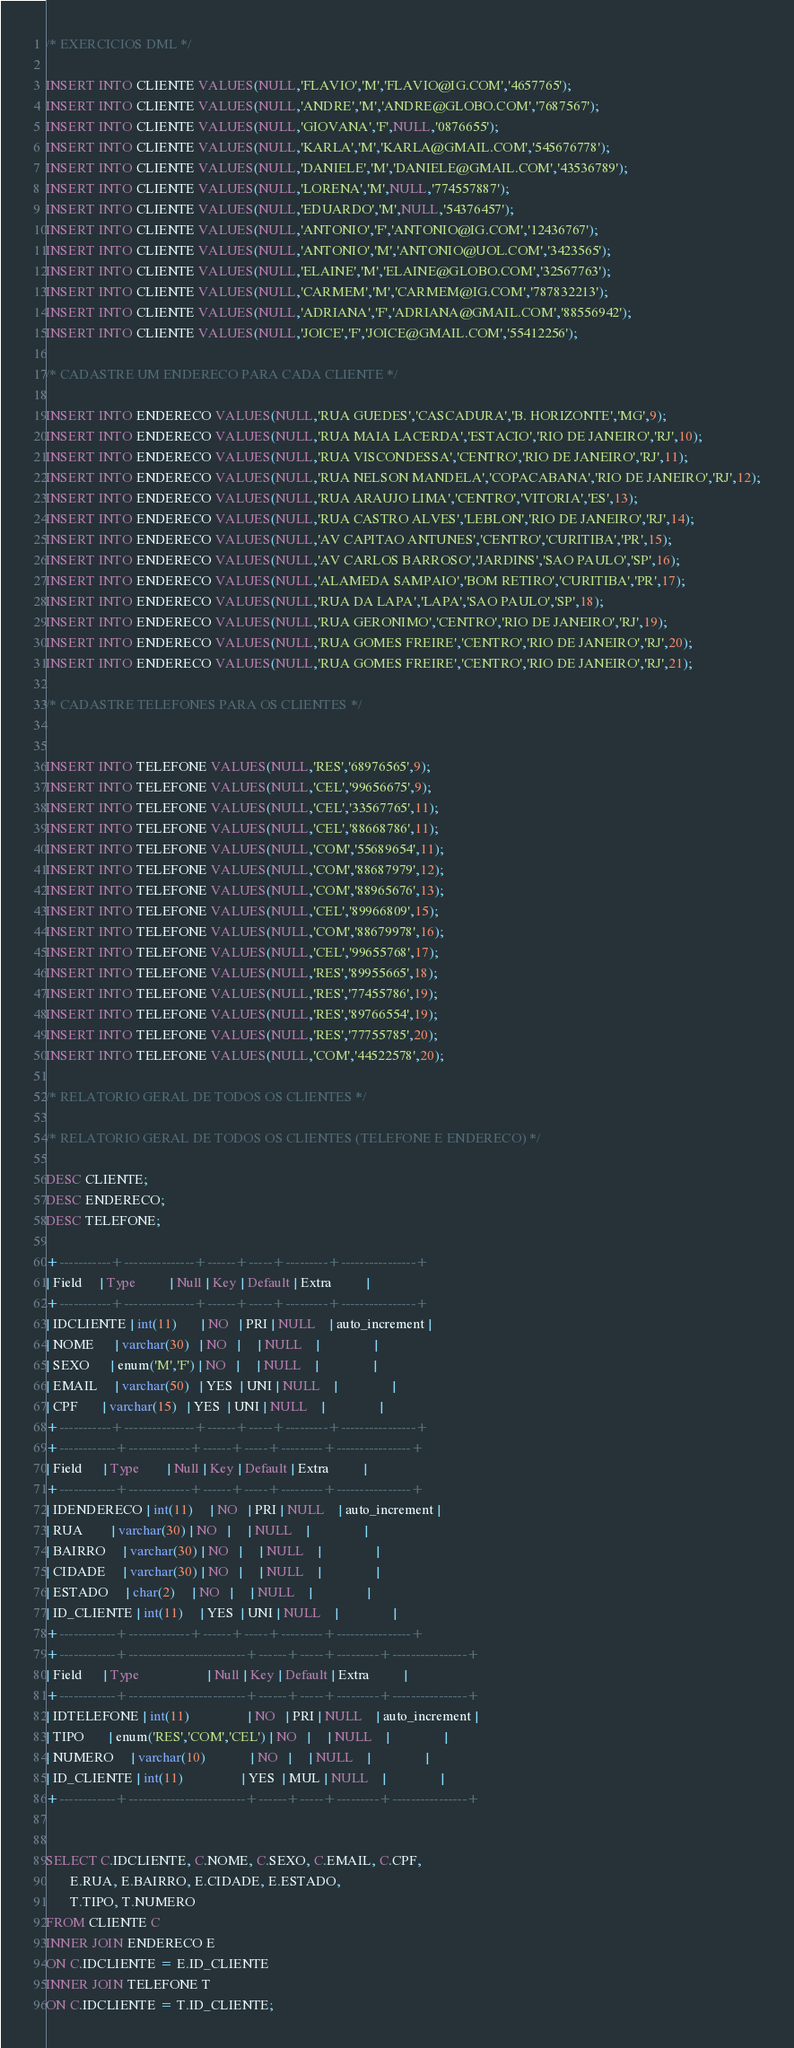<code> <loc_0><loc_0><loc_500><loc_500><_SQL_>/* EXERCICIOS DML */

INSERT INTO CLIENTE VALUES(NULL,'FLAVIO','M','FLAVIO@IG.COM','4657765');
INSERT INTO CLIENTE VALUES(NULL,'ANDRE','M','ANDRE@GLOBO.COM','7687567');
INSERT INTO CLIENTE VALUES(NULL,'GIOVANA','F',NULL,'0876655');
INSERT INTO CLIENTE VALUES(NULL,'KARLA','M','KARLA@GMAIL.COM','545676778');
INSERT INTO CLIENTE VALUES(NULL,'DANIELE','M','DANIELE@GMAIL.COM','43536789');
INSERT INTO CLIENTE VALUES(NULL,'LORENA','M',NULL,'774557887');
INSERT INTO CLIENTE VALUES(NULL,'EDUARDO','M',NULL,'54376457');
INSERT INTO CLIENTE VALUES(NULL,'ANTONIO','F','ANTONIO@IG.COM','12436767');
INSERT INTO CLIENTE VALUES(NULL,'ANTONIO','M','ANTONIO@UOL.COM','3423565');
INSERT INTO CLIENTE VALUES(NULL,'ELAINE','M','ELAINE@GLOBO.COM','32567763');
INSERT INTO CLIENTE VALUES(NULL,'CARMEM','M','CARMEM@IG.COM','787832213');
INSERT INTO CLIENTE VALUES(NULL,'ADRIANA','F','ADRIANA@GMAIL.COM','88556942');
INSERT INTO CLIENTE VALUES(NULL,'JOICE','F','JOICE@GMAIL.COM','55412256');

/* CADASTRE UM ENDERECO PARA CADA CLIENTE */

INSERT INTO ENDERECO VALUES(NULL,'RUA GUEDES','CASCADURA','B. HORIZONTE','MG',9);
INSERT INTO ENDERECO VALUES(NULL,'RUA MAIA LACERDA','ESTACIO','RIO DE JANEIRO','RJ',10);
INSERT INTO ENDERECO VALUES(NULL,'RUA VISCONDESSA','CENTRO','RIO DE JANEIRO','RJ',11);
INSERT INTO ENDERECO VALUES(NULL,'RUA NELSON MANDELA','COPACABANA','RIO DE JANEIRO','RJ',12);
INSERT INTO ENDERECO VALUES(NULL,'RUA ARAUJO LIMA','CENTRO','VITORIA','ES',13);
INSERT INTO ENDERECO VALUES(NULL,'RUA CASTRO ALVES','LEBLON','RIO DE JANEIRO','RJ',14);
INSERT INTO ENDERECO VALUES(NULL,'AV CAPITAO ANTUNES','CENTRO','CURITIBA','PR',15);
INSERT INTO ENDERECO VALUES(NULL,'AV CARLOS BARROSO','JARDINS','SAO PAULO','SP',16);
INSERT INTO ENDERECO VALUES(NULL,'ALAMEDA SAMPAIO','BOM RETIRO','CURITIBA','PR',17);
INSERT INTO ENDERECO VALUES(NULL,'RUA DA LAPA','LAPA','SAO PAULO','SP',18);
INSERT INTO ENDERECO VALUES(NULL,'RUA GERONIMO','CENTRO','RIO DE JANEIRO','RJ',19);
INSERT INTO ENDERECO VALUES(NULL,'RUA GOMES FREIRE','CENTRO','RIO DE JANEIRO','RJ',20);
INSERT INTO ENDERECO VALUES(NULL,'RUA GOMES FREIRE','CENTRO','RIO DE JANEIRO','RJ',21);

/* CADASTRE TELEFONES PARA OS CLIENTES */


INSERT INTO TELEFONE VALUES(NULL,'RES','68976565',9);
INSERT INTO TELEFONE VALUES(NULL,'CEL','99656675',9);
INSERT INTO TELEFONE VALUES(NULL,'CEL','33567765',11);
INSERT INTO TELEFONE VALUES(NULL,'CEL','88668786',11);
INSERT INTO TELEFONE VALUES(NULL,'COM','55689654',11);
INSERT INTO TELEFONE VALUES(NULL,'COM','88687979',12);
INSERT INTO TELEFONE VALUES(NULL,'COM','88965676',13);
INSERT INTO TELEFONE VALUES(NULL,'CEL','89966809',15);
INSERT INTO TELEFONE VALUES(NULL,'COM','88679978',16);
INSERT INTO TELEFONE VALUES(NULL,'CEL','99655768',17);
INSERT INTO TELEFONE VALUES(NULL,'RES','89955665',18);
INSERT INTO TELEFONE VALUES(NULL,'RES','77455786',19);
INSERT INTO TELEFONE VALUES(NULL,'RES','89766554',19);
INSERT INTO TELEFONE VALUES(NULL,'RES','77755785',20);
INSERT INTO TELEFONE VALUES(NULL,'COM','44522578',20);

/* RELATORIO GERAL DE TODOS OS CLIENTES */

/* RELATORIO GERAL DE TODOS OS CLIENTES (TELEFONE E ENDERECO) */

DESC CLIENTE;
DESC ENDERECO;
DESC TELEFONE;

+-----------+---------------+------+-----+---------+----------------+
| Field     | Type          | Null | Key | Default | Extra          |
+-----------+---------------+------+-----+---------+----------------+
| IDCLIENTE | int(11)       | NO   | PRI | NULL    | auto_increment |
| NOME      | varchar(30)   | NO   |     | NULL    |                |
| SEXO      | enum('M','F') | NO   |     | NULL    |                |
| EMAIL     | varchar(50)   | YES  | UNI | NULL    |                |
| CPF       | varchar(15)   | YES  | UNI | NULL    |                |
+-----------+---------------+------+-----+---------+----------------+
+------------+-------------+------+-----+---------+----------------+
| Field      | Type        | Null | Key | Default | Extra          |
+------------+-------------+------+-----+---------+----------------+
| IDENDERECO | int(11)     | NO   | PRI | NULL    | auto_increment |
| RUA        | varchar(30) | NO   |     | NULL    |                |
| BAIRRO     | varchar(30) | NO   |     | NULL    |                |
| CIDADE     | varchar(30) | NO   |     | NULL    |                |
| ESTADO     | char(2)     | NO   |     | NULL    |                |
| ID_CLIENTE | int(11)     | YES  | UNI | NULL    |                |
+------------+-------------+------+-----+---------+----------------+
+------------+-------------------------+------+-----+---------+----------------+
| Field      | Type                    | Null | Key | Default | Extra          |
+------------+-------------------------+------+-----+---------+----------------+
| IDTELEFONE | int(11)                 | NO   | PRI | NULL    | auto_increment |
| TIPO       | enum('RES','COM','CEL') | NO   |     | NULL    |                |
| NUMERO     | varchar(10)             | NO   |     | NULL    |                |
| ID_CLIENTE | int(11)                 | YES  | MUL | NULL    |                |
+------------+-------------------------+------+-----+---------+----------------+


SELECT C.IDCLIENTE, C.NOME, C.SEXO, C.EMAIL, C.CPF, 
	   E.RUA, E.BAIRRO, E.CIDADE, E.ESTADO, 
	   T.TIPO, T.NUMERO
FROM CLIENTE C
INNER JOIN ENDERECO E
ON C.IDCLIENTE = E.ID_CLIENTE
INNER JOIN TELEFONE T
ON C.IDCLIENTE = T.ID_CLIENTE;

</code> 